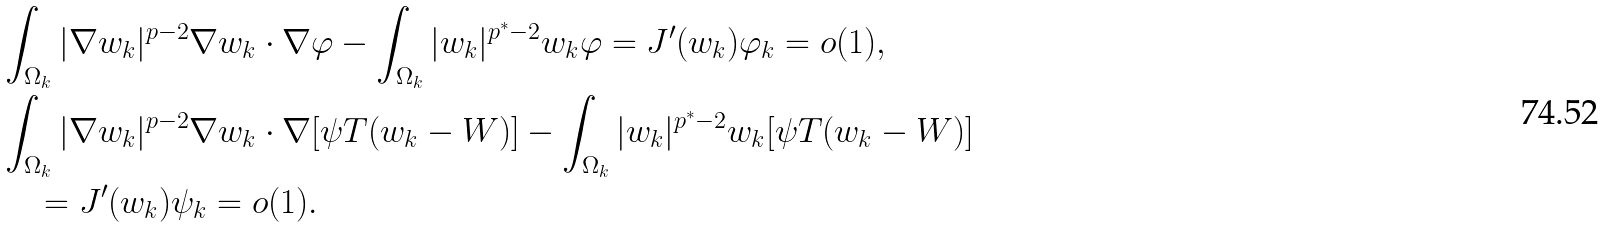<formula> <loc_0><loc_0><loc_500><loc_500>& \int _ { \Omega _ { k } } | \nabla w _ { k } | ^ { p - 2 } \nabla w _ { k } \cdot \nabla \varphi - \int _ { \Omega _ { k } } | w _ { k } | ^ { p ^ { * } - 2 } w _ { k } \varphi = J ^ { \prime } ( w _ { k } ) \varphi _ { k } = o ( 1 ) , \\ & \int _ { \Omega _ { k } } | \nabla w _ { k } | ^ { p - 2 } \nabla w _ { k } \cdot \nabla [ \psi T ( w _ { k } - W ) ] - \int _ { \Omega _ { k } } | w _ { k } | ^ { p ^ { * } - 2 } w _ { k } [ \psi T ( w _ { k } - W ) ] \\ & \quad = J ^ { \prime } ( w _ { k } ) \psi _ { k } = o ( 1 ) .</formula> 